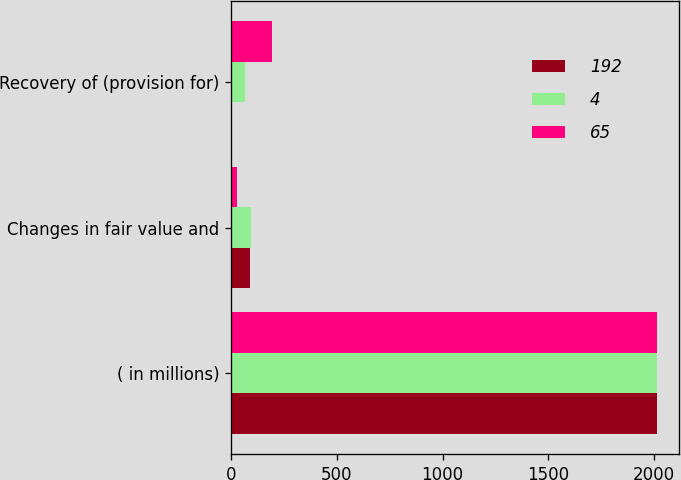<chart> <loc_0><loc_0><loc_500><loc_500><stacked_bar_chart><ecel><fcel>( in millions)<fcel>Changes in fair value and<fcel>Recovery of (provision for)<nl><fcel>192<fcel>2015<fcel>90<fcel>4<nl><fcel>4<fcel>2014<fcel>95<fcel>65<nl><fcel>65<fcel>2013<fcel>30<fcel>192<nl></chart> 